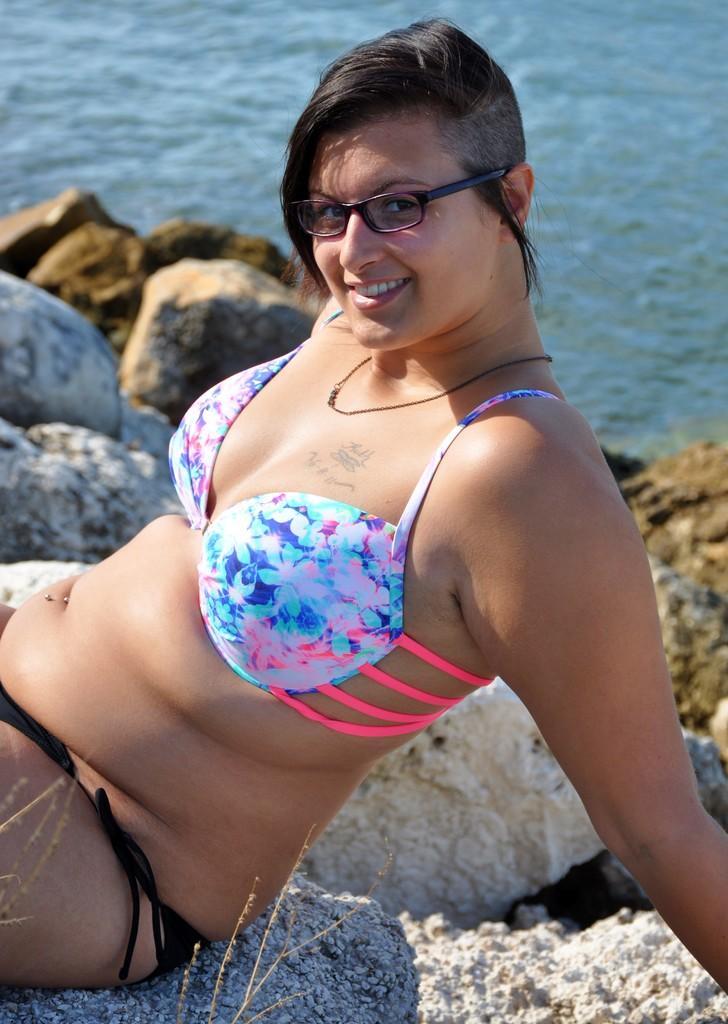How would you summarize this image in a sentence or two? In this image we can see a lady sitting on the rock. In the background there is water and we can see rocks. 